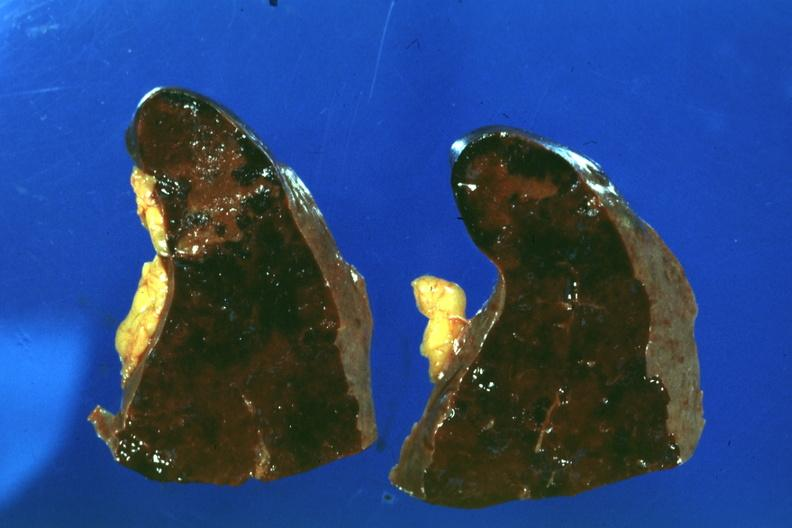does this image show congested spleen infarct easily seen?
Answer the question using a single word or phrase. Yes 